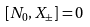Convert formula to latex. <formula><loc_0><loc_0><loc_500><loc_500>[ N _ { 0 } , X _ { \pm } ] = 0</formula> 